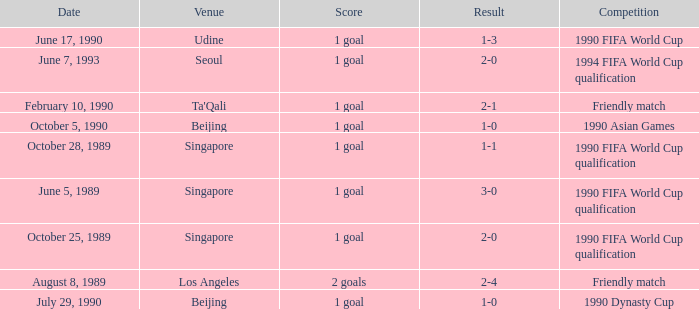What was the venue where the result was 2-1? Ta'Qali. 